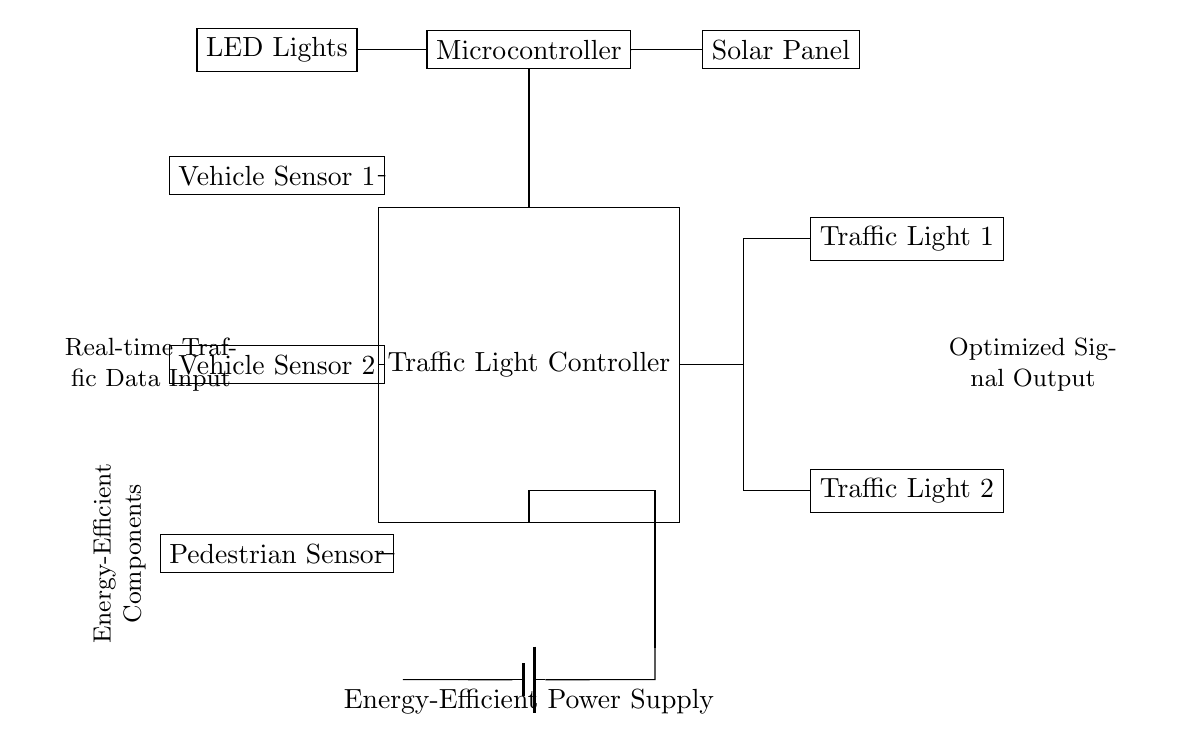What is the function of the microcontroller in this circuit? The microcontroller processes input from the vehicle and pedestrian sensors and controls the traffic lights based on real-time traffic data.
Answer: Traffic management What type of power supply is used in this circuit? The power supply is described as an energy-efficient power supply, which likely includes sustainable or low-energy components to minimize power consumption.
Answer: Energy-efficient How many sensors are present in the circuit? There are three sensors: two vehicle sensors and one pedestrian sensor, indicated by the labeled blocks connected to the controller.
Answer: Three sensors Which component generates energy for this circuit? The solar panel is indicated as a key component that harnesses solar energy to power the circuit, supporting energy efficiency.
Answer: Solar panel Which lights are used in this traffic control system? The circuit diagram indicates that LED lights are used for the traffic lights, which are known for their low energy consumption and long lifespan.
Answer: LED lights What is the connection type between the controller and the traffic lights? The diagram shows that the connection is made with a line that indicates output from the controller leading to both traffic lights, implying a controlled output signal.
Answer: Output signal connection How does this circuit optimize urban traffic flow? The circuit receives real-time data from sensors and adjusts the traffic light signals accordingly to reduce wait times and improve traffic efficiency.
Answer: Real-time optimization 